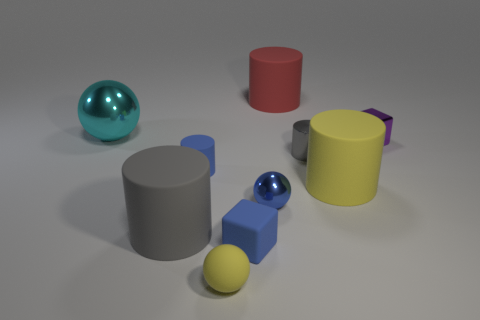Is there a gray rubber thing?
Offer a terse response. Yes. How many other things are the same size as the purple block?
Make the answer very short. 5. Is the big gray object made of the same material as the cylinder that is to the right of the metallic cylinder?
Your response must be concise. Yes. Are there the same number of small metallic cylinders that are to the left of the big gray cylinder and big yellow rubber objects behind the large metallic sphere?
Offer a very short reply. Yes. What is the material of the tiny yellow sphere?
Provide a succinct answer. Rubber. There is a shiny cylinder that is the same size as the purple shiny cube; what is its color?
Give a very brief answer. Gray. Is there a large shiny object to the left of the blue thing left of the yellow ball?
Ensure brevity in your answer.  Yes. What number of spheres are small shiny objects or metallic objects?
Ensure brevity in your answer.  2. There is a metallic ball behind the small cylinder that is behind the blue thing behind the yellow cylinder; how big is it?
Offer a terse response. Large. Are there any tiny blue balls in front of the small matte cylinder?
Your answer should be very brief. Yes. 